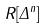<formula> <loc_0><loc_0><loc_500><loc_500>R [ \Delta ^ { n } ]</formula> 